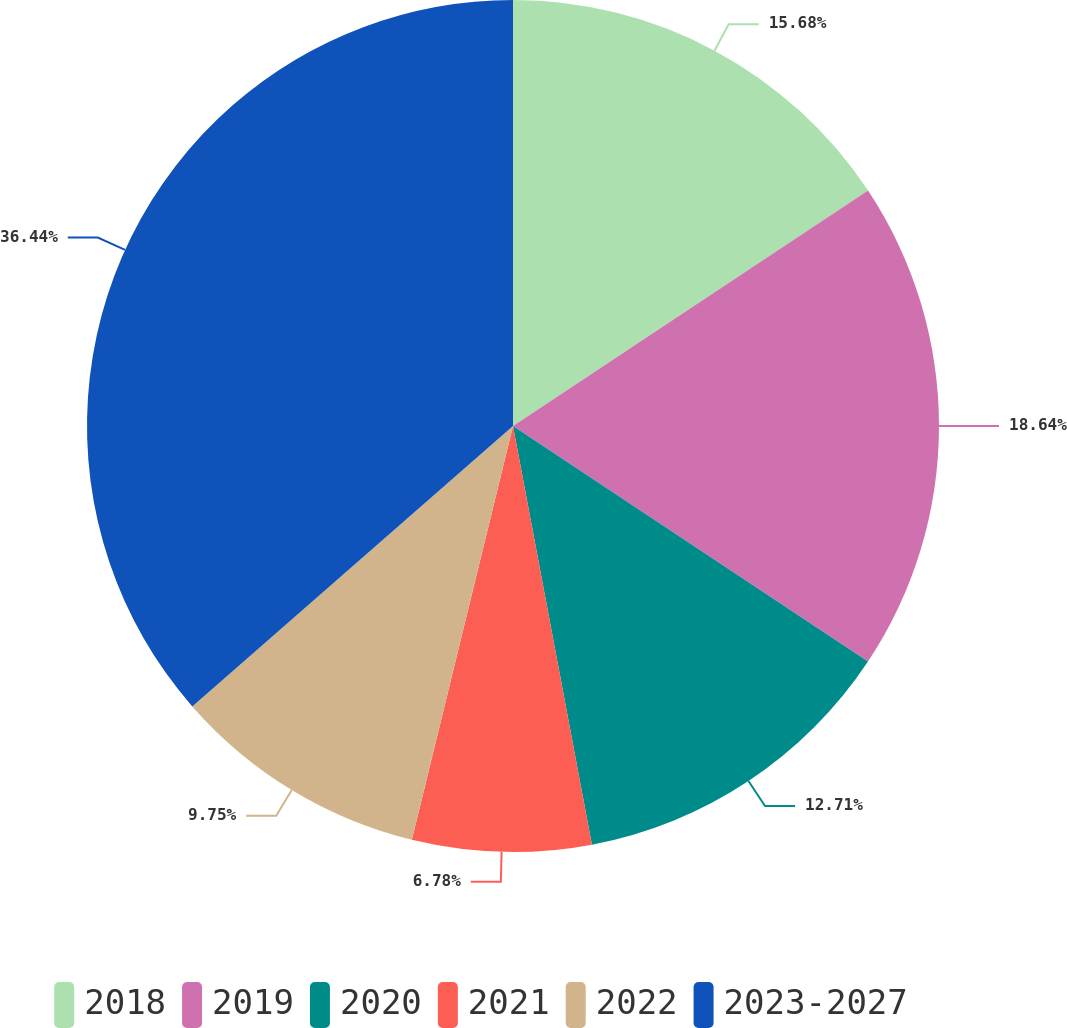Convert chart to OTSL. <chart><loc_0><loc_0><loc_500><loc_500><pie_chart><fcel>2018<fcel>2019<fcel>2020<fcel>2021<fcel>2022<fcel>2023-2027<nl><fcel>15.68%<fcel>18.64%<fcel>12.71%<fcel>6.78%<fcel>9.75%<fcel>36.43%<nl></chart> 